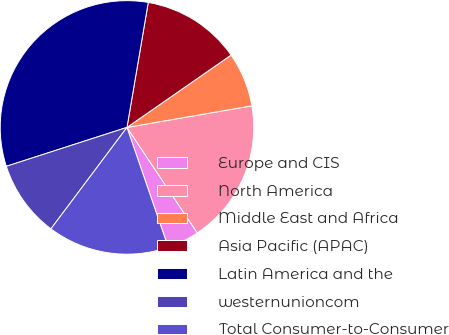<chart> <loc_0><loc_0><loc_500><loc_500><pie_chart><fcel>Europe and CIS<fcel>North America<fcel>Middle East and Africa<fcel>Asia Pacific (APAC)<fcel>Latin America and the<fcel>westernunioncom<fcel>Total Consumer-to-Consumer<nl><fcel>4.08%<fcel>18.37%<fcel>6.94%<fcel>12.65%<fcel>32.65%<fcel>9.8%<fcel>15.51%<nl></chart> 